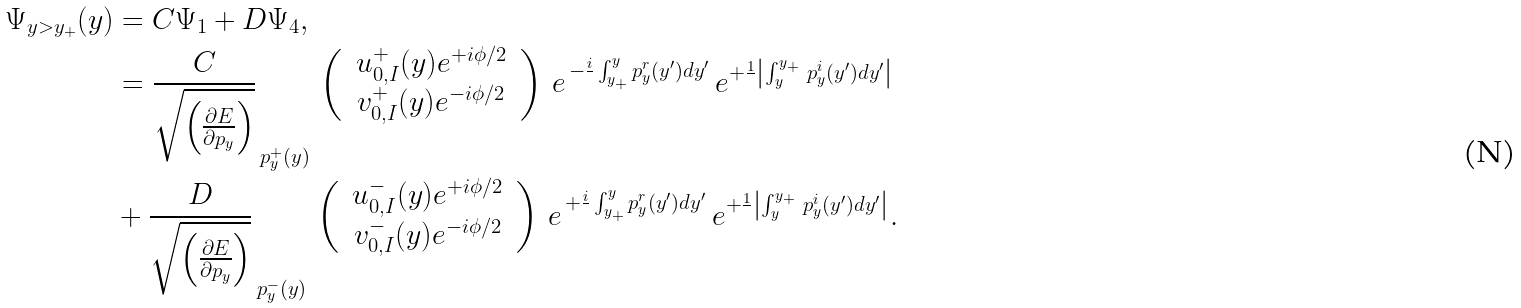<formula> <loc_0><loc_0><loc_500><loc_500>\Psi _ { y > y _ { + } } ( y ) & = C \Psi _ { 1 } + D \Psi _ { 4 } , \\ & = \frac { C } { \sqrt { \left ( \frac { \partial E } { \partial p _ { y } } \right ) } } _ { \, p _ { y } ^ { + } ( y ) } \, \left ( \, \begin{array} { c } u ^ { + } _ { 0 , I } ( y ) e ^ { + i \phi / 2 } \\ v ^ { + } _ { 0 , I } ( y ) e ^ { - i \phi / 2 } \end{array} \, \right ) \, e ^ { \, - \frac { i } { } \int _ { y _ { + } } ^ { y } p _ { y } ^ { r } ( y ^ { \prime } ) d y ^ { \prime } } \, e ^ { + \frac { 1 } { } \left | \int _ { y } ^ { y _ { + } } \, p _ { y } ^ { i } ( y ^ { \prime } ) d y ^ { \prime } \right | } \\ & + \frac { D } { \sqrt { \left ( \frac { \partial E } { \partial p _ { y } } \right ) } } _ { \, p _ { y } ^ { - } ( y ) } \, \left ( \, \begin{array} { c } u ^ { - } _ { 0 , I } ( y ) e ^ { + i \phi / 2 } \\ v ^ { - } _ { 0 , I } ( y ) e ^ { - i \phi / 2 } \end{array} \, \right ) \, e ^ { \, + \frac { i } { } \int _ { y _ { + } } ^ { y } p _ { y } ^ { r } ( y ^ { \prime } ) d y ^ { \prime } } \, e ^ { + \frac { 1 } { } \left | \int _ { y } ^ { y _ { + } } \, p _ { y } ^ { i } ( y ^ { \prime } ) d y ^ { \prime } \right | } .</formula> 